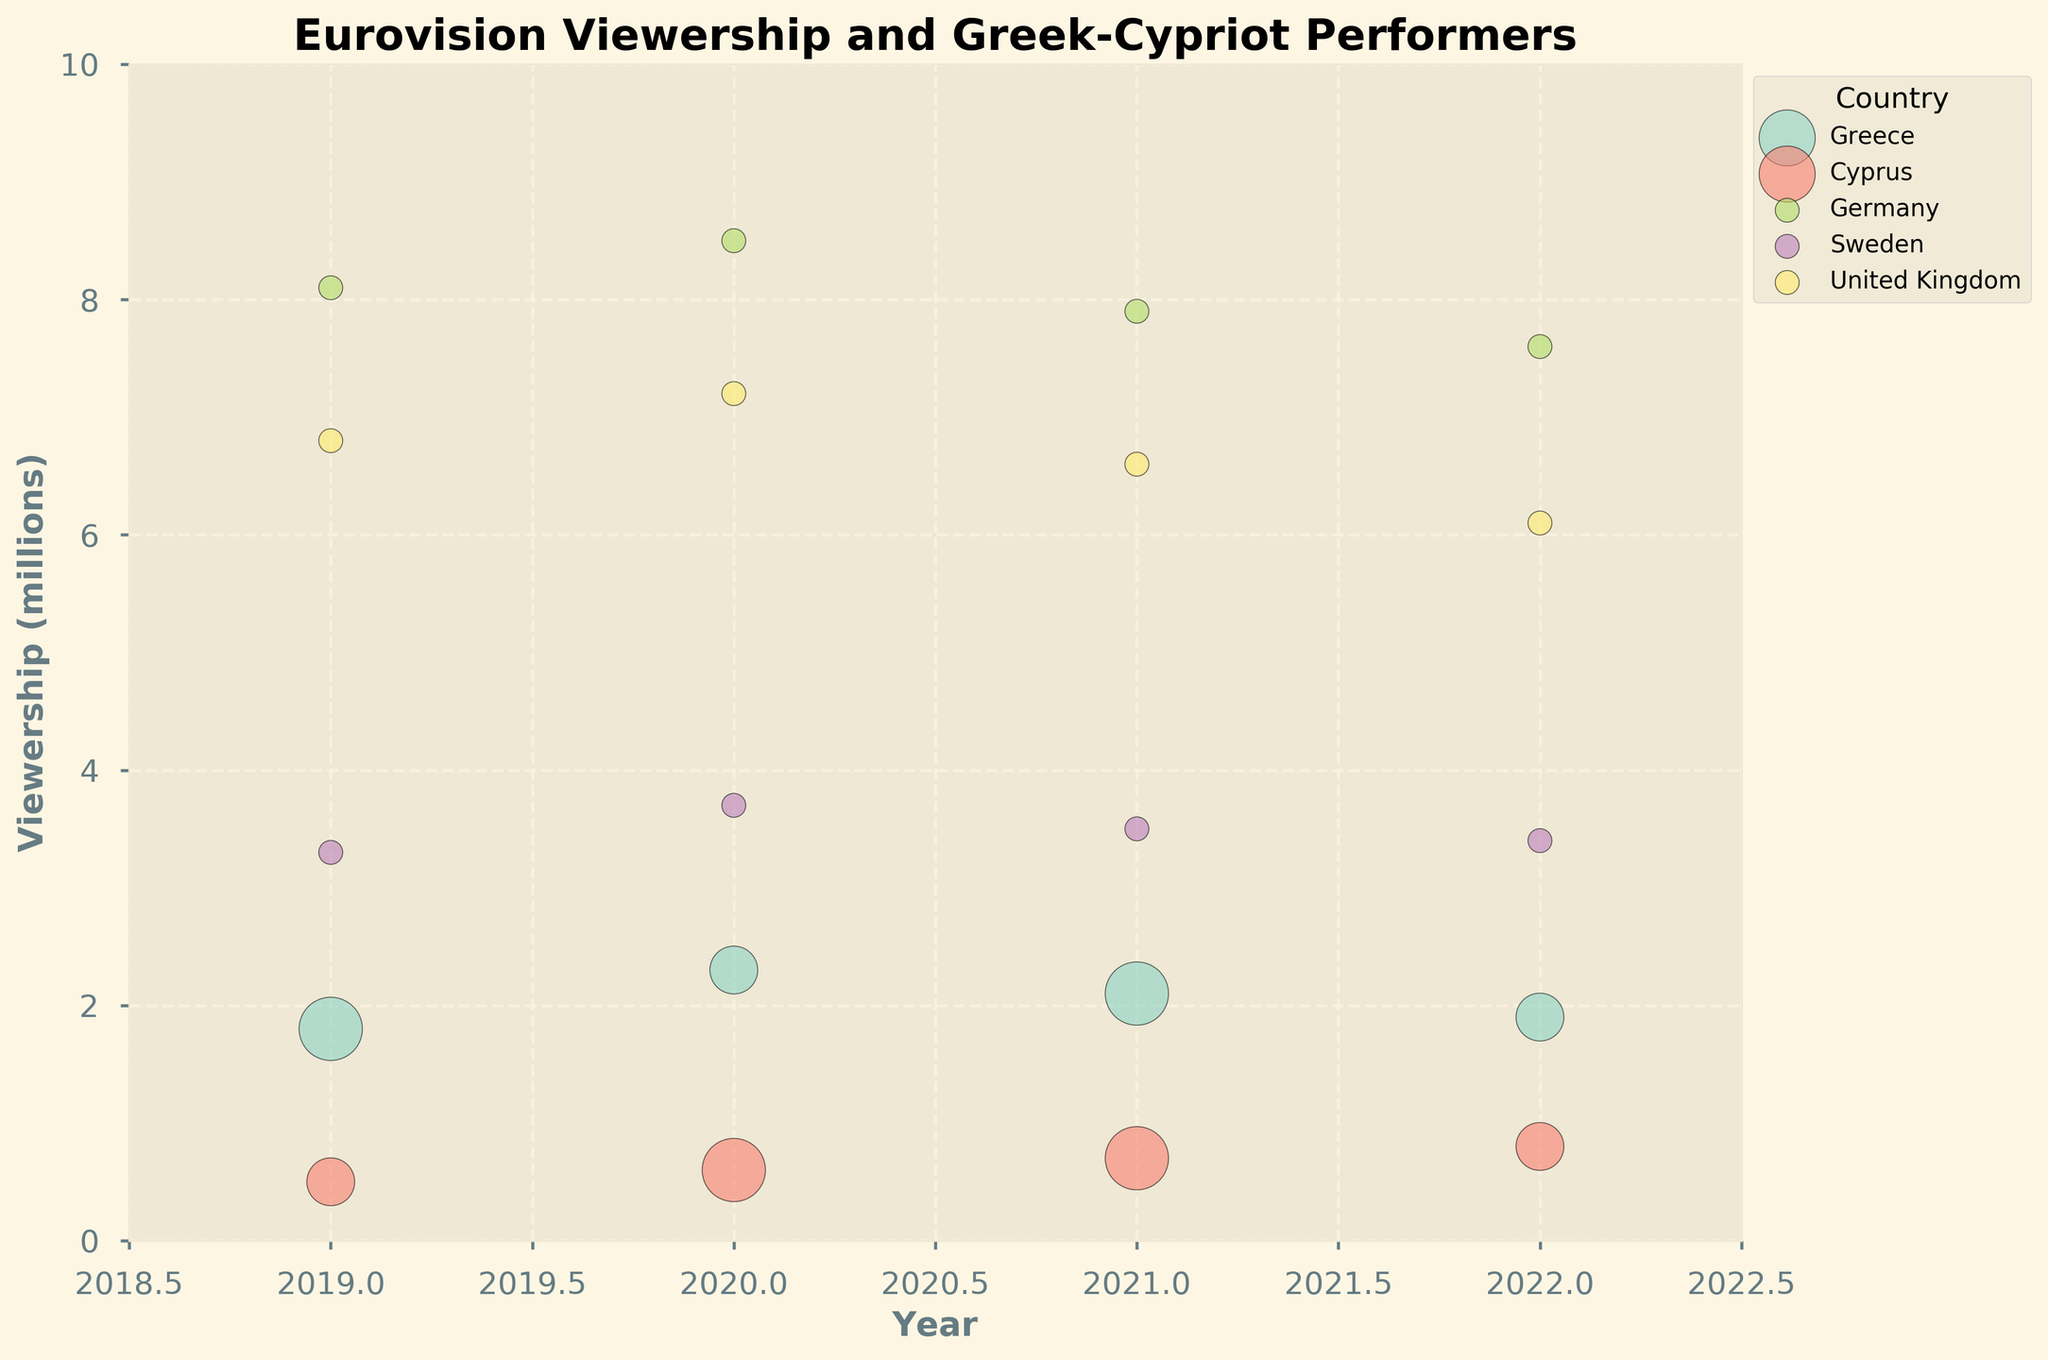How does the viewership of Eurovision in Greece vary from 2019 to 2022? From 2019 to 2022, the viewership in Greece fluctuated as follows: 1.8 million in 2019, 2.3 million in 2020, 2.1 million in 2021, and 1.9 million in 2022.
Answer: Fluctuates between 1.8 and 2.3 million How do the performers of Greek-Cypriot descent impact the viewership in Cyprus? The number of performers of Greek-Cypriot descent in Cyprus slightly increases from one in 2019 to two in 2020 and 2021, and then decreases to one in 2022. The viewership correspondingly rises from 0.5 million in 2019 to 0.8 million in 2022, indicating a possible correlation.
Answer: Correlated increase Which country had the highest viewership in 2022? By looking at the data points for 2022, Germany had the highest viewership at 7.6 million.
Answer: Germany What is the trend in viewership for the United Kingdom from 2019 to 2022? The viewership in the United Kingdom shows a declining trend from 6.8 million in 2019 to 6.1 million in 2022.
Answer: Declining Which country consistently had no performers of Greek-Cypriot descent from 2019 to 2022? Germany, Sweden, and the United Kingdom show data points with no Greek-Cypriot descent performers in all observed years (all bubbles have the smallest size).
Answer: Germany, Sweden, and the United Kingdom Did Greece or Cyprus have a higher viewership in 2020? Comparing the data points for 2020, Greece had a higher viewership of 2.3 million compared to Cyprus at 0.6 million.
Answer: Greece How does the size of the bubbles for Greece in 2021 compare to 2019? The size of the bubbles represents the number of performers. Greece had two performers in both 2019 and 2021, so the bubble sizes are similar.
Answer: Similar What can be inferred from the bubble size and viewership for Cyprus between 2020 and 2021? Both years have two performers of Greek-Cypriot descent, indicated by similarly sized bubbles. Viewership increased from 0.6 million in 2020 to 0.7 million in 2021, suggesting a possible positive impact of these performers on viewership.
Answer: Increase in viewership How does the viewership trend in Germany from 2019 to 2022 compare to Sweden in the same period? Germany's viewership shows a decline from 8.1 million in 2019 to 7.6 million in 2022. Similarly, Sweden's viewership decreases from 3.3 million in 2019 to 3.4 million in 2022.
Answer: Both declining Between 2019 and 2022, in which country did the viewership increase the most in absolute numbers? By examining the viewership numbers, Cyprus shows the highest absolute increase from 0.5 million in 2019 to 0.8 million in 2022, an increase of 0.3 million.
Answer: Cyprus 